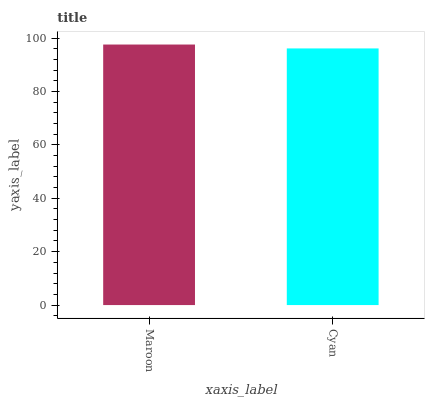Is Cyan the minimum?
Answer yes or no. Yes. Is Maroon the maximum?
Answer yes or no. Yes. Is Cyan the maximum?
Answer yes or no. No. Is Maroon greater than Cyan?
Answer yes or no. Yes. Is Cyan less than Maroon?
Answer yes or no. Yes. Is Cyan greater than Maroon?
Answer yes or no. No. Is Maroon less than Cyan?
Answer yes or no. No. Is Maroon the high median?
Answer yes or no. Yes. Is Cyan the low median?
Answer yes or no. Yes. Is Cyan the high median?
Answer yes or no. No. Is Maroon the low median?
Answer yes or no. No. 